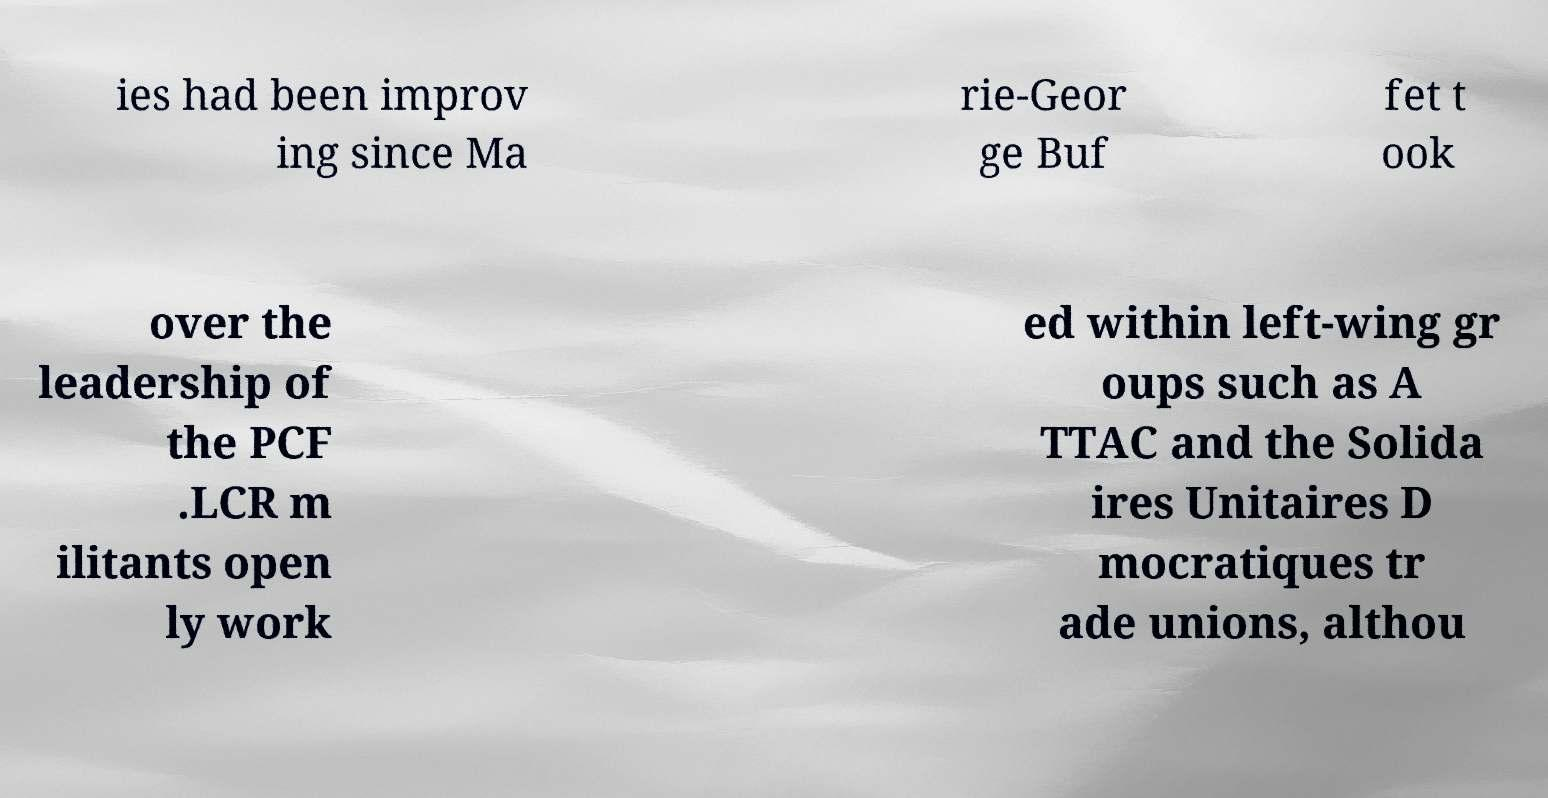What messages or text are displayed in this image? I need them in a readable, typed format. ies had been improv ing since Ma rie-Geor ge Buf fet t ook over the leadership of the PCF .LCR m ilitants open ly work ed within left-wing gr oups such as A TTAC and the Solida ires Unitaires D mocratiques tr ade unions, althou 